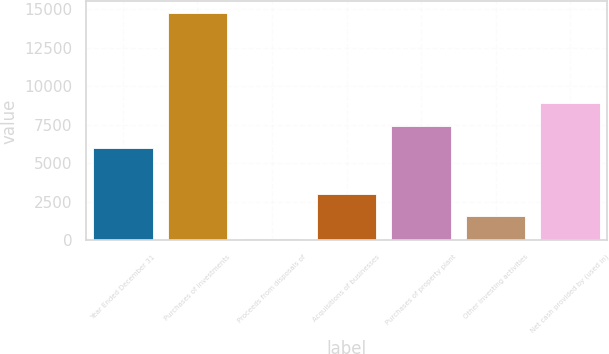Convert chart to OTSL. <chart><loc_0><loc_0><loc_500><loc_500><bar_chart><fcel>Year Ended December 31<fcel>Purchases of investments<fcel>Proceeds from disposals of<fcel>Acquisitions of businesses<fcel>Purchases of property plant<fcel>Other investing activities<fcel>Net cash provided by (used in)<nl><fcel>5979.4<fcel>14782<fcel>111<fcel>3045.2<fcel>7446.5<fcel>1578.1<fcel>8913.6<nl></chart> 